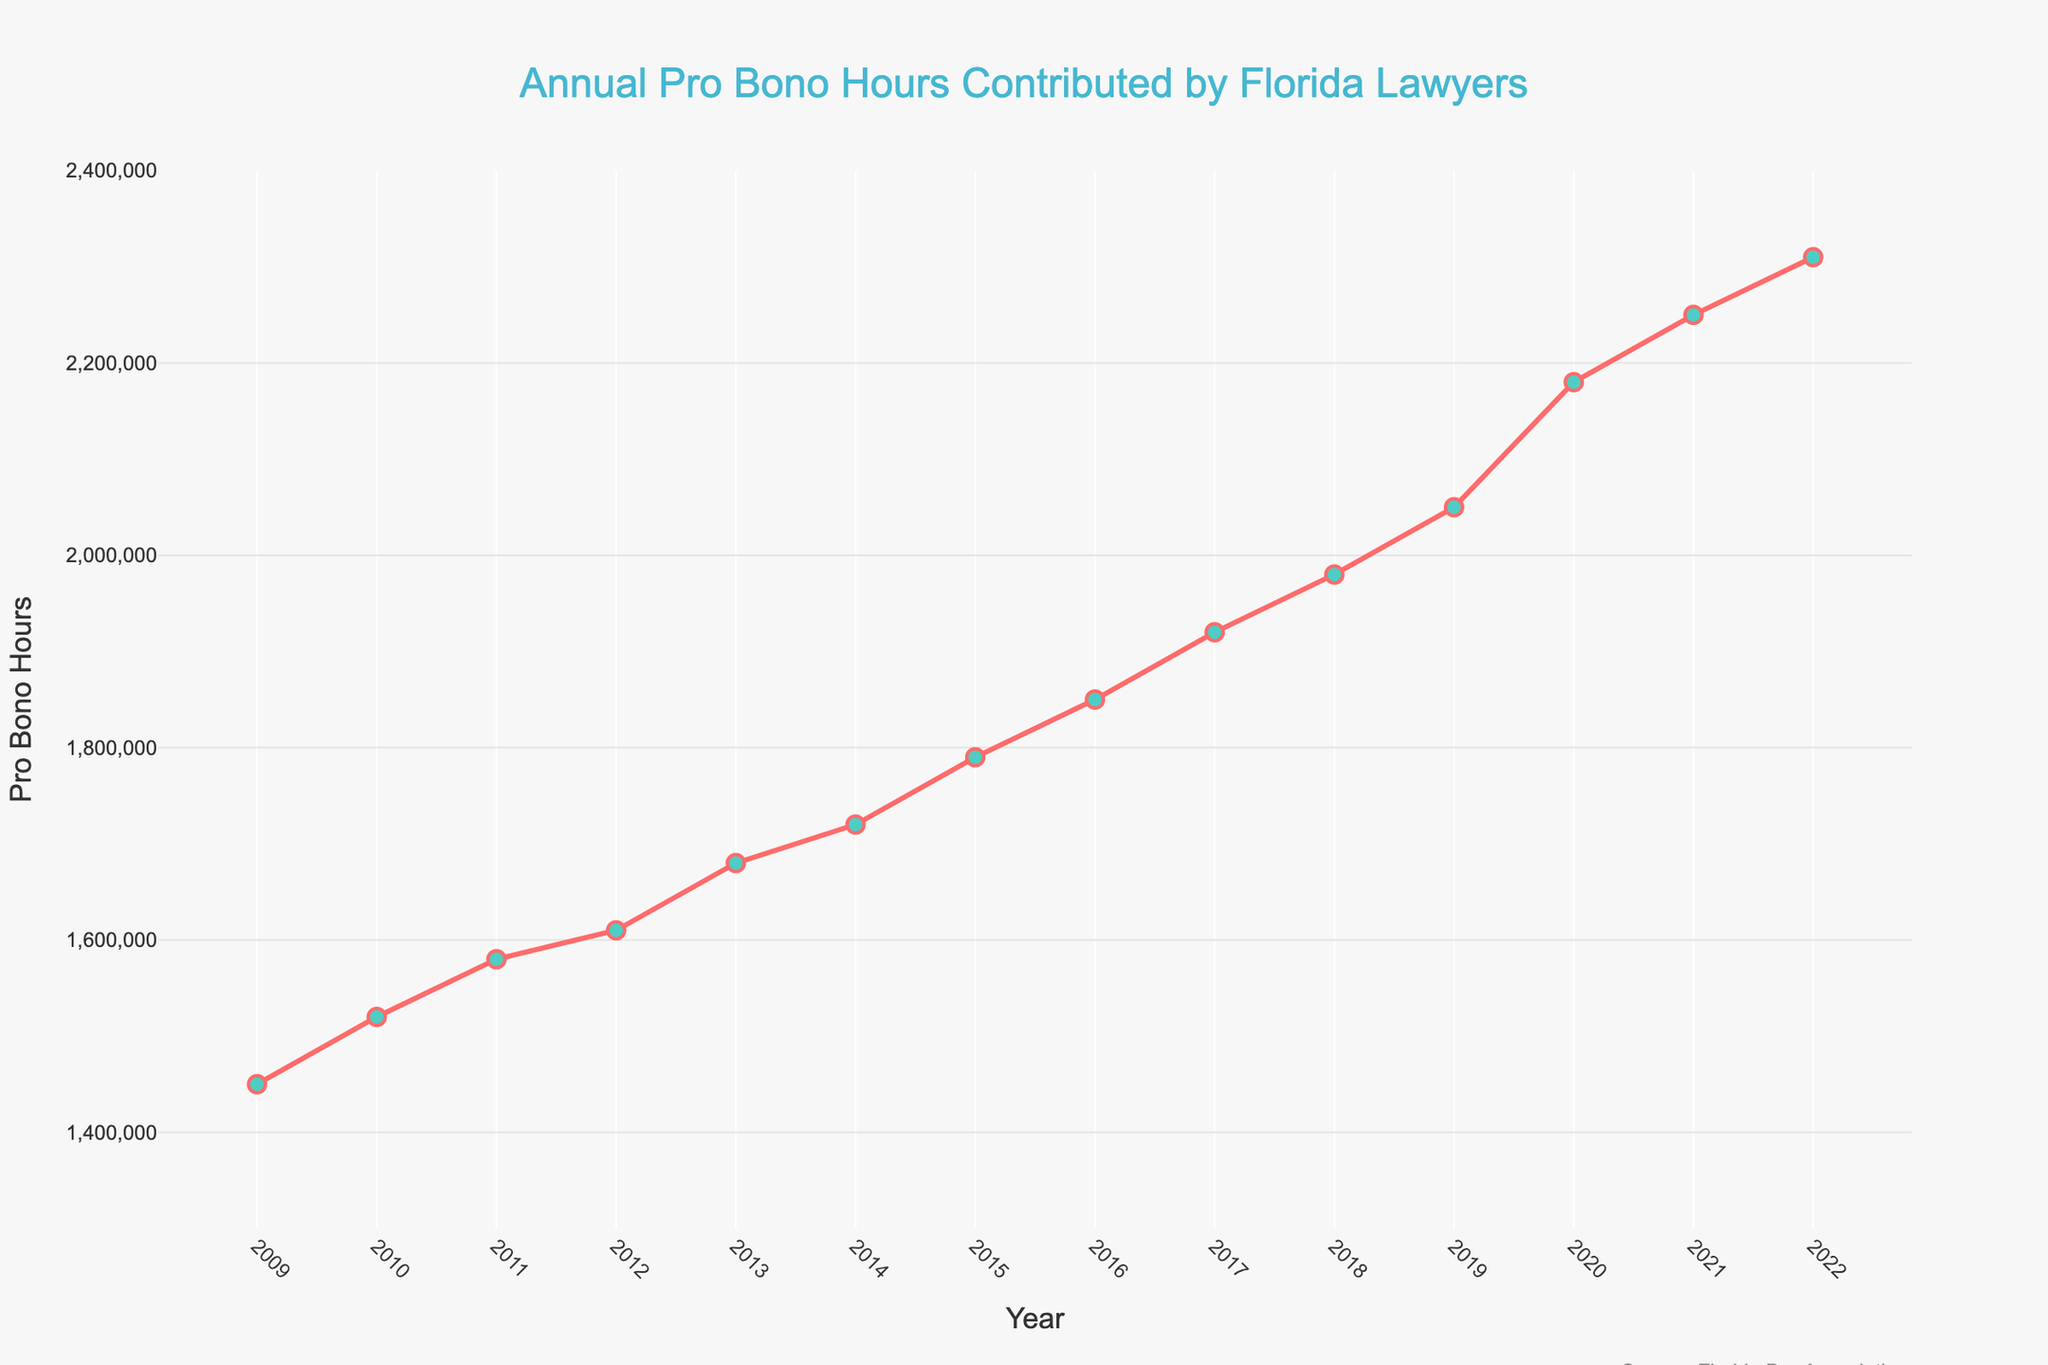When did Florida lawyers contribute the most pro bono hours? According to the figure, the peak contribution occurred in 2022 with the highest value on the Y-axis.
Answer: 2022 Which year showed the largest increase in pro bono hours compared to the previous year? To find this, compare the differences between consecutive years on the Y-axis. From 2019 to 2020, the increase was 1,300,000, the largest on the graph.
Answer: 2019 to 2020 What is the average number of pro bono hours contributed annually from 2009 to 2022? Sum all the annual pro bono hours listed on the Y-axis, and divide by the number of years (14). (1450000 + 1520000 + 1580000 + 1610000 + 1680000 + 1720000 + 1790000 + 1850000 + 1920000 + 1980000 + 2050000 + 2180000 + 2250000 + 2310000)/14 = 1830714.29
Answer: 1,830,714.29 Between which consecutive years did the pro bono hours remain almost constant? Look for a segment where the line is nearly flat. Between 2011 and 2012, the contribution hours increased only by 30,000, relatively flat.
Answer: 2011 to 2012 Was the trend in pro bono hours always increasing? Examine the line; there are no segments where the line decreases, indicating a continuously increasing trend.
Answer: Yes In which year did Florida lawyers contribute 2,050,000 pro bono hours? Locate the point on the Y-axis corresponding to 2,050,000 and find the associated year on the X-axis, which is 2019.
Answer: 2019 What is the total number of pro bono hours contributed from 2009 to 2022? Add all the values listed on the Y-axis together: 1450000 + 1520000 + 1580000 + 1610000 + 1680000 + 1720000 + 1790000 + 1850000 + 1920000 + 1980000 + 2050000 + 2180000 + 2250000 + 2310000 = 25630000
Answer: 25,630,000 How much more pro bono hours were contributed in 2022 compared to 2009? Subtract the hours in 2009 from those in 2022: 2310000 - 1450000 = 860000
Answer: 860,000 What is the percentage increase in pro bono hours from 2009 to 2022? Calculate the percentage increase: (2310000 - 1450000) / 1450000 * 100 = 59
Answer: 59% How does the contribution in 2016 compare to the contribution in 2011? Compare the hours in 2016 (1,850,000) and 2011 (1,580,000). 1850000 - 1580000 = 270000, indicating 2016 had 270,000 more hours.
Answer: 270,000 